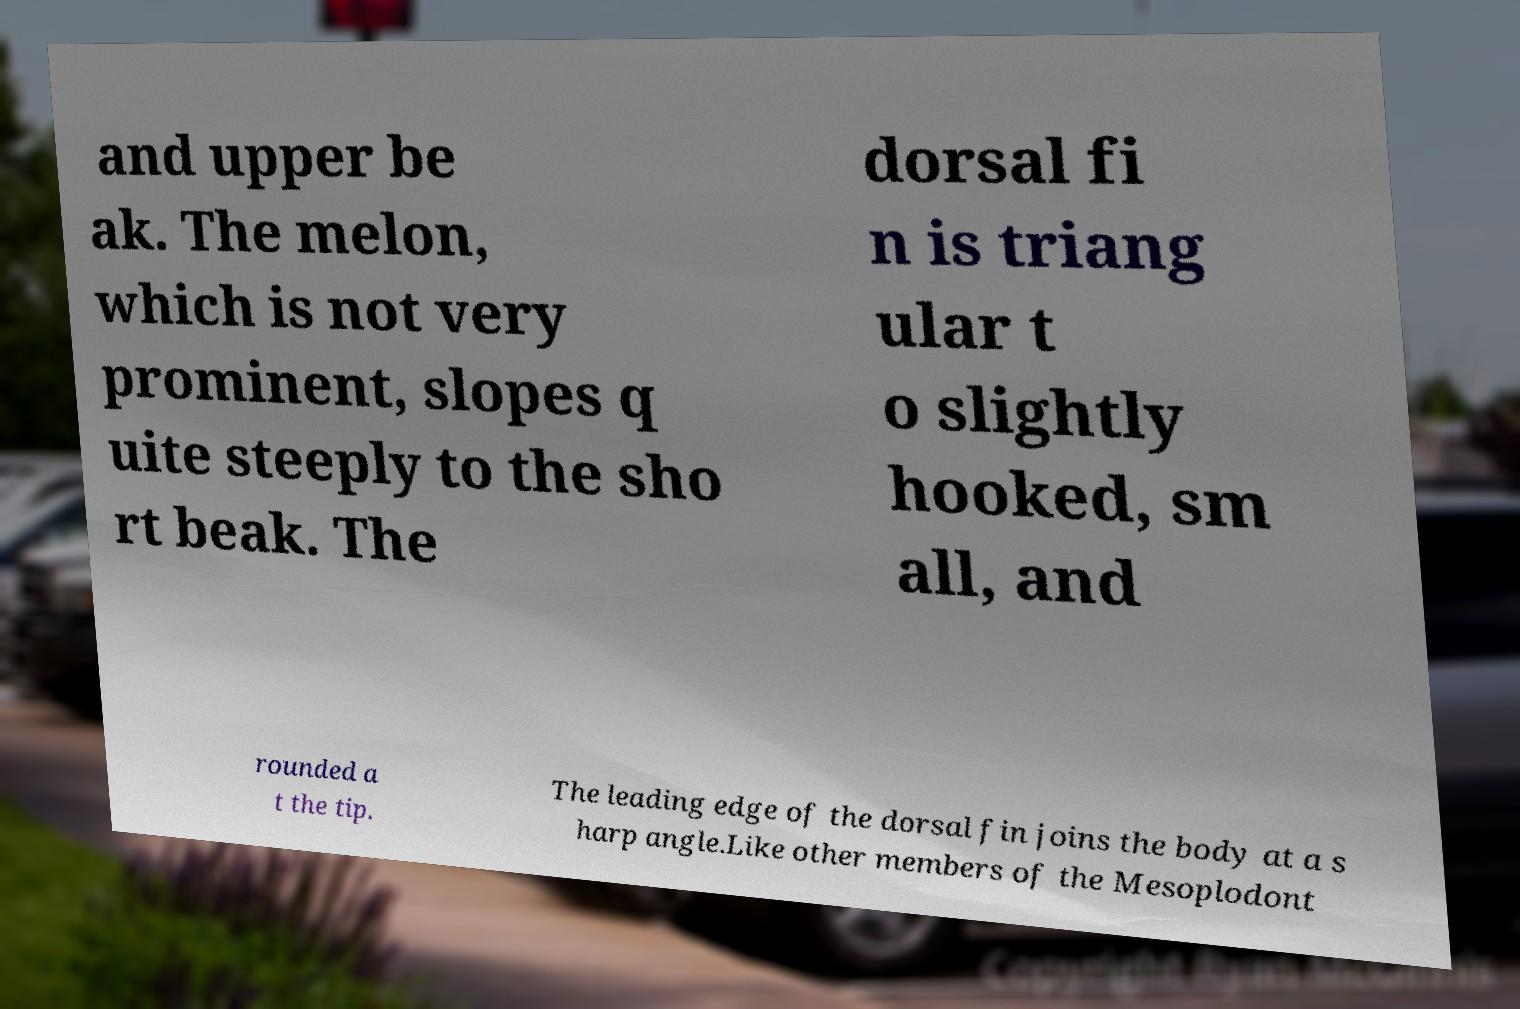Please read and relay the text visible in this image. What does it say? and upper be ak. The melon, which is not very prominent, slopes q uite steeply to the sho rt beak. The dorsal fi n is triang ular t o slightly hooked, sm all, and rounded a t the tip. The leading edge of the dorsal fin joins the body at a s harp angle.Like other members of the Mesoplodont 